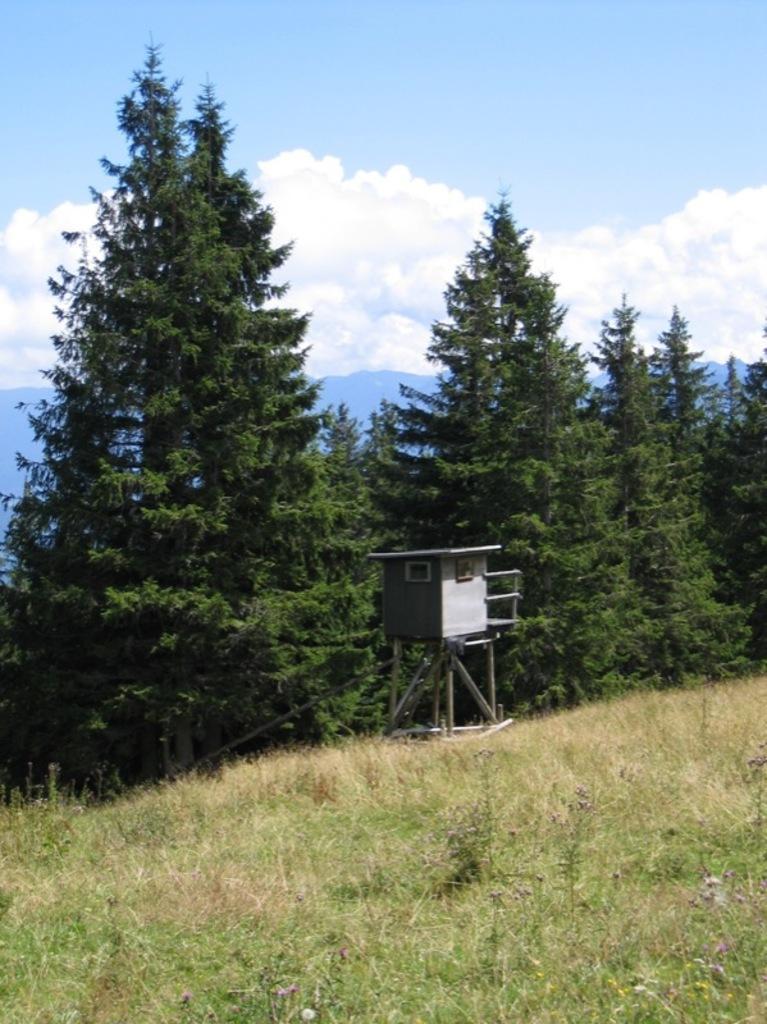Can you describe this image briefly? In the background we can see the sky with clouds, trees. There is an object placed near to the trees. At the bottom we can see the grass. 